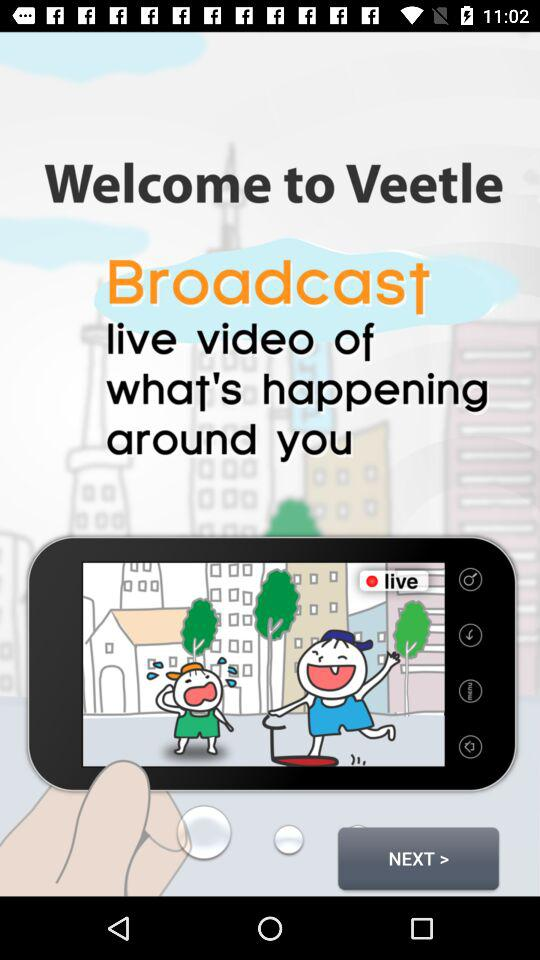What is the application name? The application name is "Veetle". 